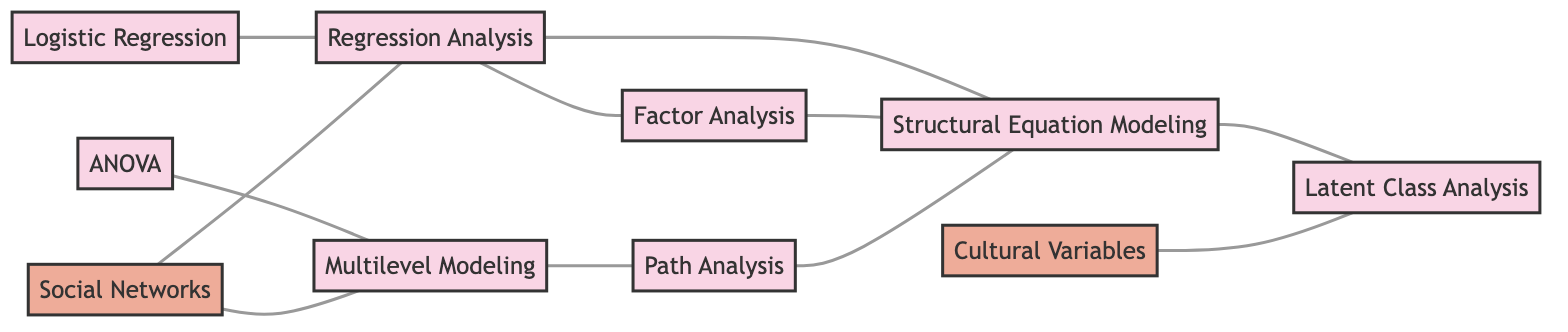What is the total number of nodes in the diagram? To find the total number of nodes, we count each unique technique and construct listed in the nodes section of the diagram. There are 10 distinct nodes representing statistical techniques and sociological constructs.
Answer: 10 Which statistical technique is directly linked to "Cultural Variables"? By examining the links in the diagram, we see that "Cultural Variables" is connected to "Latent Class Analysis".
Answer: Latent Class Analysis How many edges connect "Regression Analysis" to other nodes? We review the links related to "Regression Analysis". It is linked to "Factor Analysis", "Structural Equation Modeling", "Logistic Regression", and "Social Networks", totaling four edges.
Answer: 4 What are the two statistical techniques connected to "Multilevel Modeling"? We look for the nodes linked directly to "Multilevel Modeling" and find it is connected to "ANOVA" and "Path Analysis".
Answer: ANOVA, Path Analysis Which statistical technique connects the most other techniques? Analyzing the diagram, "Structural Equation Modeling" connects to three techniques: "Regression Analysis", "Factor Analysis", and "Latent Class Analysis". No other technique connects more than three, making it the most connected.
Answer: Structural Equation Modeling Does "Social Networks" connect to more statistical techniques than "Cultural Variables"? By reviewing the connections, "Social Networks" links to "Regression Analysis" and "Multilevel Modeling" (two techniques), whereas "Cultural Variables" links only to "Latent Class Analysis" (one technique). Therefore, "Social Networks" has more connections.
Answer: Yes How many sociological constructs are depicted in the diagram? Counting the nodes categorized under "Sociological Constructs", we find two nodes: "Cultural Variables" and "Social Networks".
Answer: 2 Is "Logistic Regression" associated with any sociological constructs? The links for "Logistic Regression" indicate connections only to "Regression Analysis" and no sociological constructs, so it does not connect to any.
Answer: No 